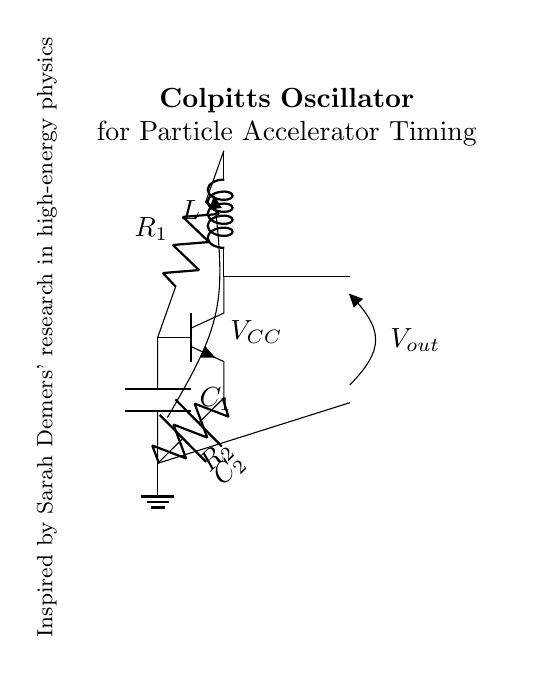What type of oscillator is shown in the diagram? The diagram depicts a Colpitts oscillator, which is characterized by its use of capacitors and an inductor. The presence of two capacitors and one inductor in the schematic leads to this identification.
Answer: Colpitts oscillator What is the source voltage in this circuit? The voltage source is labeled as V subscript CC. This is indicated directly in the circuit diagram, where a voltage source is connected to the circuit.
Answer: V subscript CC How many capacitors are in the circuit? There are two capacitors present in the circuit, labeled C subscript 1 and C subscript 2, as indicated by their representations in the circuit diagram.
Answer: 2 What does the output voltage represent in this oscillator circuit? The output voltage, labeled as V subscript out, indicates the voltage produced at the output of the oscillator. This output voltage is a key parameter for evaluating the oscillator's performance.
Answer: V subscript out Which components determine the oscillation frequency in this circuit? The oscillation frequency is determined mainly by the inductor (L) and the two capacitors (C subscript 1 and C subscript 2). The relationship between these components influences the resonant frequency of the oscillator, following the formula that includes these elements.
Answer: L, C subscript 1, C subscript 2 What is the role of the transistor in this oscillator circuit? The transistor acts as an amplifying device, enabling the Colpitts oscillator to generate the necessary oscillations. It determines the gain in the feedback loop of the circuit.
Answer: Amplifier How does the configuration of capacitors affect the oscillator's stability? The configuration of the two capacitors impacts the feedback fraction in the circuit, influencing its stability. In a Colpitts oscillator, this setup can lead to improved stability by setting a specific voltage division.
Answer: Affects feedback fraction 